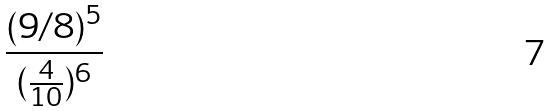Convert formula to latex. <formula><loc_0><loc_0><loc_500><loc_500>\frac { ( 9 / 8 ) ^ { 5 } } { ( \frac { 4 } { 1 0 } ) ^ { 6 } }</formula> 